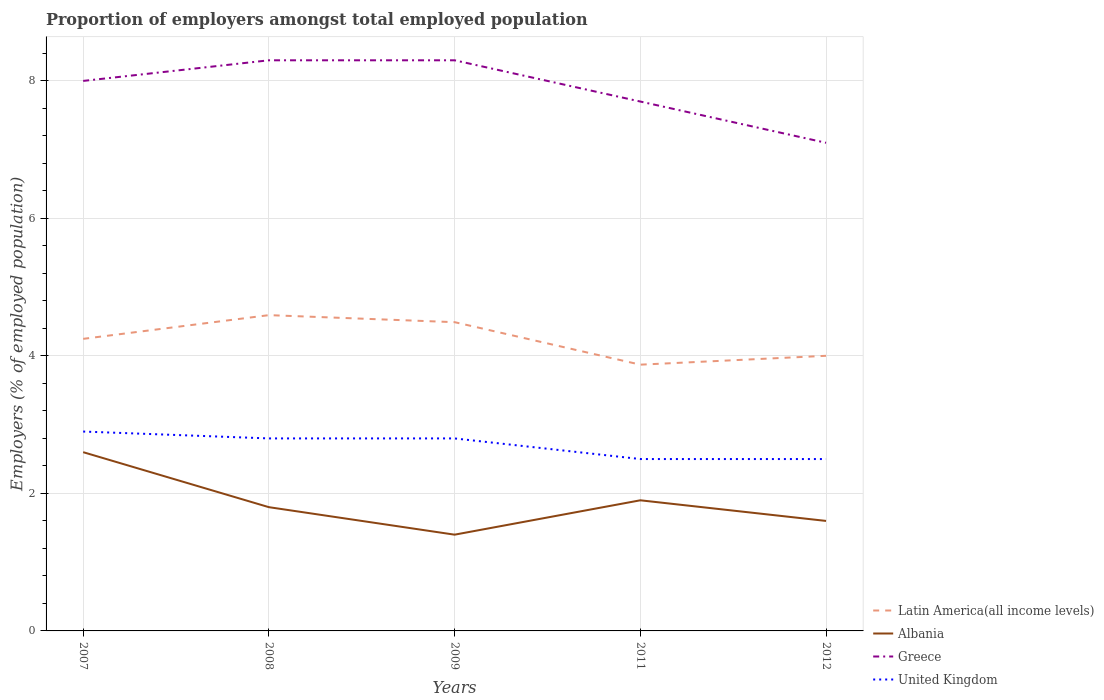How many different coloured lines are there?
Offer a very short reply. 4. Does the line corresponding to Latin America(all income levels) intersect with the line corresponding to United Kingdom?
Your response must be concise. No. What is the total proportion of employers in United Kingdom in the graph?
Ensure brevity in your answer.  0.4. What is the difference between the highest and the second highest proportion of employers in Greece?
Your answer should be very brief. 1.2. What is the difference between the highest and the lowest proportion of employers in Greece?
Ensure brevity in your answer.  3. Is the proportion of employers in Greece strictly greater than the proportion of employers in United Kingdom over the years?
Provide a short and direct response. No. What is the difference between two consecutive major ticks on the Y-axis?
Your response must be concise. 2. Does the graph contain grids?
Provide a short and direct response. Yes. Where does the legend appear in the graph?
Keep it short and to the point. Bottom right. What is the title of the graph?
Make the answer very short. Proportion of employers amongst total employed population. What is the label or title of the Y-axis?
Keep it short and to the point. Employers (% of employed population). What is the Employers (% of employed population) of Latin America(all income levels) in 2007?
Make the answer very short. 4.25. What is the Employers (% of employed population) in Albania in 2007?
Offer a terse response. 2.6. What is the Employers (% of employed population) of Greece in 2007?
Offer a terse response. 8. What is the Employers (% of employed population) in United Kingdom in 2007?
Offer a terse response. 2.9. What is the Employers (% of employed population) of Latin America(all income levels) in 2008?
Your answer should be very brief. 4.59. What is the Employers (% of employed population) in Albania in 2008?
Provide a succinct answer. 1.8. What is the Employers (% of employed population) of Greece in 2008?
Keep it short and to the point. 8.3. What is the Employers (% of employed population) in United Kingdom in 2008?
Your answer should be very brief. 2.8. What is the Employers (% of employed population) of Latin America(all income levels) in 2009?
Your response must be concise. 4.49. What is the Employers (% of employed population) of Albania in 2009?
Provide a succinct answer. 1.4. What is the Employers (% of employed population) in Greece in 2009?
Provide a succinct answer. 8.3. What is the Employers (% of employed population) in United Kingdom in 2009?
Ensure brevity in your answer.  2.8. What is the Employers (% of employed population) in Latin America(all income levels) in 2011?
Your answer should be compact. 3.87. What is the Employers (% of employed population) in Albania in 2011?
Offer a terse response. 1.9. What is the Employers (% of employed population) in Greece in 2011?
Offer a very short reply. 7.7. What is the Employers (% of employed population) in Latin America(all income levels) in 2012?
Give a very brief answer. 4. What is the Employers (% of employed population) in Albania in 2012?
Give a very brief answer. 1.6. What is the Employers (% of employed population) of Greece in 2012?
Offer a terse response. 7.1. Across all years, what is the maximum Employers (% of employed population) in Latin America(all income levels)?
Keep it short and to the point. 4.59. Across all years, what is the maximum Employers (% of employed population) of Albania?
Your answer should be compact. 2.6. Across all years, what is the maximum Employers (% of employed population) in Greece?
Provide a succinct answer. 8.3. Across all years, what is the maximum Employers (% of employed population) in United Kingdom?
Ensure brevity in your answer.  2.9. Across all years, what is the minimum Employers (% of employed population) of Latin America(all income levels)?
Offer a terse response. 3.87. Across all years, what is the minimum Employers (% of employed population) in Albania?
Provide a succinct answer. 1.4. Across all years, what is the minimum Employers (% of employed population) in Greece?
Offer a terse response. 7.1. Across all years, what is the minimum Employers (% of employed population) of United Kingdom?
Your answer should be very brief. 2.5. What is the total Employers (% of employed population) in Latin America(all income levels) in the graph?
Your response must be concise. 21.21. What is the total Employers (% of employed population) of Albania in the graph?
Keep it short and to the point. 9.3. What is the total Employers (% of employed population) in Greece in the graph?
Keep it short and to the point. 39.4. What is the difference between the Employers (% of employed population) in Latin America(all income levels) in 2007 and that in 2008?
Offer a very short reply. -0.34. What is the difference between the Employers (% of employed population) of Albania in 2007 and that in 2008?
Keep it short and to the point. 0.8. What is the difference between the Employers (% of employed population) in Greece in 2007 and that in 2008?
Offer a very short reply. -0.3. What is the difference between the Employers (% of employed population) of United Kingdom in 2007 and that in 2008?
Ensure brevity in your answer.  0.1. What is the difference between the Employers (% of employed population) in Latin America(all income levels) in 2007 and that in 2009?
Your response must be concise. -0.24. What is the difference between the Employers (% of employed population) of Albania in 2007 and that in 2009?
Provide a short and direct response. 1.2. What is the difference between the Employers (% of employed population) of Greece in 2007 and that in 2009?
Provide a succinct answer. -0.3. What is the difference between the Employers (% of employed population) in Latin America(all income levels) in 2007 and that in 2011?
Keep it short and to the point. 0.38. What is the difference between the Employers (% of employed population) in Albania in 2007 and that in 2011?
Your answer should be compact. 0.7. What is the difference between the Employers (% of employed population) in Greece in 2007 and that in 2011?
Provide a succinct answer. 0.3. What is the difference between the Employers (% of employed population) in United Kingdom in 2007 and that in 2011?
Keep it short and to the point. 0.4. What is the difference between the Employers (% of employed population) in Latin America(all income levels) in 2007 and that in 2012?
Make the answer very short. 0.25. What is the difference between the Employers (% of employed population) of Greece in 2007 and that in 2012?
Keep it short and to the point. 0.9. What is the difference between the Employers (% of employed population) of United Kingdom in 2007 and that in 2012?
Offer a very short reply. 0.4. What is the difference between the Employers (% of employed population) in Latin America(all income levels) in 2008 and that in 2009?
Ensure brevity in your answer.  0.1. What is the difference between the Employers (% of employed population) in Albania in 2008 and that in 2009?
Your answer should be compact. 0.4. What is the difference between the Employers (% of employed population) in United Kingdom in 2008 and that in 2009?
Your answer should be very brief. 0. What is the difference between the Employers (% of employed population) of Latin America(all income levels) in 2008 and that in 2011?
Make the answer very short. 0.72. What is the difference between the Employers (% of employed population) in Latin America(all income levels) in 2008 and that in 2012?
Your response must be concise. 0.59. What is the difference between the Employers (% of employed population) of Greece in 2008 and that in 2012?
Offer a terse response. 1.2. What is the difference between the Employers (% of employed population) of United Kingdom in 2008 and that in 2012?
Keep it short and to the point. 0.3. What is the difference between the Employers (% of employed population) of Latin America(all income levels) in 2009 and that in 2011?
Provide a short and direct response. 0.62. What is the difference between the Employers (% of employed population) of Albania in 2009 and that in 2011?
Your answer should be very brief. -0.5. What is the difference between the Employers (% of employed population) of Greece in 2009 and that in 2011?
Provide a short and direct response. 0.6. What is the difference between the Employers (% of employed population) in Latin America(all income levels) in 2009 and that in 2012?
Your answer should be compact. 0.49. What is the difference between the Employers (% of employed population) in Albania in 2009 and that in 2012?
Your answer should be compact. -0.2. What is the difference between the Employers (% of employed population) in United Kingdom in 2009 and that in 2012?
Your answer should be compact. 0.3. What is the difference between the Employers (% of employed population) of Latin America(all income levels) in 2011 and that in 2012?
Your answer should be compact. -0.13. What is the difference between the Employers (% of employed population) in Greece in 2011 and that in 2012?
Provide a succinct answer. 0.6. What is the difference between the Employers (% of employed population) of Latin America(all income levels) in 2007 and the Employers (% of employed population) of Albania in 2008?
Ensure brevity in your answer.  2.45. What is the difference between the Employers (% of employed population) in Latin America(all income levels) in 2007 and the Employers (% of employed population) in Greece in 2008?
Your answer should be compact. -4.05. What is the difference between the Employers (% of employed population) in Latin America(all income levels) in 2007 and the Employers (% of employed population) in United Kingdom in 2008?
Ensure brevity in your answer.  1.45. What is the difference between the Employers (% of employed population) of Albania in 2007 and the Employers (% of employed population) of Greece in 2008?
Give a very brief answer. -5.7. What is the difference between the Employers (% of employed population) of Latin America(all income levels) in 2007 and the Employers (% of employed population) of Albania in 2009?
Offer a very short reply. 2.85. What is the difference between the Employers (% of employed population) in Latin America(all income levels) in 2007 and the Employers (% of employed population) in Greece in 2009?
Your response must be concise. -4.05. What is the difference between the Employers (% of employed population) of Latin America(all income levels) in 2007 and the Employers (% of employed population) of United Kingdom in 2009?
Your answer should be very brief. 1.45. What is the difference between the Employers (% of employed population) in Latin America(all income levels) in 2007 and the Employers (% of employed population) in Albania in 2011?
Provide a succinct answer. 2.35. What is the difference between the Employers (% of employed population) in Latin America(all income levels) in 2007 and the Employers (% of employed population) in Greece in 2011?
Ensure brevity in your answer.  -3.45. What is the difference between the Employers (% of employed population) in Latin America(all income levels) in 2007 and the Employers (% of employed population) in United Kingdom in 2011?
Offer a terse response. 1.75. What is the difference between the Employers (% of employed population) of Albania in 2007 and the Employers (% of employed population) of United Kingdom in 2011?
Make the answer very short. 0.1. What is the difference between the Employers (% of employed population) of Greece in 2007 and the Employers (% of employed population) of United Kingdom in 2011?
Your answer should be very brief. 5.5. What is the difference between the Employers (% of employed population) of Latin America(all income levels) in 2007 and the Employers (% of employed population) of Albania in 2012?
Keep it short and to the point. 2.65. What is the difference between the Employers (% of employed population) of Latin America(all income levels) in 2007 and the Employers (% of employed population) of Greece in 2012?
Provide a succinct answer. -2.85. What is the difference between the Employers (% of employed population) in Latin America(all income levels) in 2007 and the Employers (% of employed population) in United Kingdom in 2012?
Provide a succinct answer. 1.75. What is the difference between the Employers (% of employed population) in Latin America(all income levels) in 2008 and the Employers (% of employed population) in Albania in 2009?
Your answer should be compact. 3.19. What is the difference between the Employers (% of employed population) of Latin America(all income levels) in 2008 and the Employers (% of employed population) of Greece in 2009?
Give a very brief answer. -3.71. What is the difference between the Employers (% of employed population) in Latin America(all income levels) in 2008 and the Employers (% of employed population) in United Kingdom in 2009?
Offer a very short reply. 1.79. What is the difference between the Employers (% of employed population) of Albania in 2008 and the Employers (% of employed population) of United Kingdom in 2009?
Your response must be concise. -1. What is the difference between the Employers (% of employed population) in Greece in 2008 and the Employers (% of employed population) in United Kingdom in 2009?
Offer a very short reply. 5.5. What is the difference between the Employers (% of employed population) in Latin America(all income levels) in 2008 and the Employers (% of employed population) in Albania in 2011?
Ensure brevity in your answer.  2.69. What is the difference between the Employers (% of employed population) of Latin America(all income levels) in 2008 and the Employers (% of employed population) of Greece in 2011?
Your answer should be compact. -3.11. What is the difference between the Employers (% of employed population) in Latin America(all income levels) in 2008 and the Employers (% of employed population) in United Kingdom in 2011?
Your answer should be compact. 2.09. What is the difference between the Employers (% of employed population) in Albania in 2008 and the Employers (% of employed population) in Greece in 2011?
Offer a terse response. -5.9. What is the difference between the Employers (% of employed population) in Latin America(all income levels) in 2008 and the Employers (% of employed population) in Albania in 2012?
Offer a very short reply. 2.99. What is the difference between the Employers (% of employed population) of Latin America(all income levels) in 2008 and the Employers (% of employed population) of Greece in 2012?
Ensure brevity in your answer.  -2.51. What is the difference between the Employers (% of employed population) in Latin America(all income levels) in 2008 and the Employers (% of employed population) in United Kingdom in 2012?
Provide a succinct answer. 2.09. What is the difference between the Employers (% of employed population) of Albania in 2008 and the Employers (% of employed population) of Greece in 2012?
Offer a very short reply. -5.3. What is the difference between the Employers (% of employed population) of Albania in 2008 and the Employers (% of employed population) of United Kingdom in 2012?
Your answer should be very brief. -0.7. What is the difference between the Employers (% of employed population) in Latin America(all income levels) in 2009 and the Employers (% of employed population) in Albania in 2011?
Make the answer very short. 2.59. What is the difference between the Employers (% of employed population) in Latin America(all income levels) in 2009 and the Employers (% of employed population) in Greece in 2011?
Offer a very short reply. -3.21. What is the difference between the Employers (% of employed population) of Latin America(all income levels) in 2009 and the Employers (% of employed population) of United Kingdom in 2011?
Provide a succinct answer. 1.99. What is the difference between the Employers (% of employed population) in Albania in 2009 and the Employers (% of employed population) in Greece in 2011?
Ensure brevity in your answer.  -6.3. What is the difference between the Employers (% of employed population) of Albania in 2009 and the Employers (% of employed population) of United Kingdom in 2011?
Provide a short and direct response. -1.1. What is the difference between the Employers (% of employed population) of Latin America(all income levels) in 2009 and the Employers (% of employed population) of Albania in 2012?
Offer a very short reply. 2.89. What is the difference between the Employers (% of employed population) in Latin America(all income levels) in 2009 and the Employers (% of employed population) in Greece in 2012?
Offer a terse response. -2.61. What is the difference between the Employers (% of employed population) in Latin America(all income levels) in 2009 and the Employers (% of employed population) in United Kingdom in 2012?
Your answer should be compact. 1.99. What is the difference between the Employers (% of employed population) of Albania in 2009 and the Employers (% of employed population) of Greece in 2012?
Your response must be concise. -5.7. What is the difference between the Employers (% of employed population) of Albania in 2009 and the Employers (% of employed population) of United Kingdom in 2012?
Offer a very short reply. -1.1. What is the difference between the Employers (% of employed population) in Latin America(all income levels) in 2011 and the Employers (% of employed population) in Albania in 2012?
Provide a succinct answer. 2.27. What is the difference between the Employers (% of employed population) in Latin America(all income levels) in 2011 and the Employers (% of employed population) in Greece in 2012?
Offer a terse response. -3.23. What is the difference between the Employers (% of employed population) in Latin America(all income levels) in 2011 and the Employers (% of employed population) in United Kingdom in 2012?
Your answer should be very brief. 1.37. What is the difference between the Employers (% of employed population) in Albania in 2011 and the Employers (% of employed population) in Greece in 2012?
Offer a very short reply. -5.2. What is the difference between the Employers (% of employed population) in Albania in 2011 and the Employers (% of employed population) in United Kingdom in 2012?
Offer a very short reply. -0.6. What is the average Employers (% of employed population) in Latin America(all income levels) per year?
Give a very brief answer. 4.24. What is the average Employers (% of employed population) of Albania per year?
Keep it short and to the point. 1.86. What is the average Employers (% of employed population) in Greece per year?
Give a very brief answer. 7.88. In the year 2007, what is the difference between the Employers (% of employed population) of Latin America(all income levels) and Employers (% of employed population) of Albania?
Ensure brevity in your answer.  1.65. In the year 2007, what is the difference between the Employers (% of employed population) in Latin America(all income levels) and Employers (% of employed population) in Greece?
Ensure brevity in your answer.  -3.75. In the year 2007, what is the difference between the Employers (% of employed population) in Latin America(all income levels) and Employers (% of employed population) in United Kingdom?
Give a very brief answer. 1.35. In the year 2007, what is the difference between the Employers (% of employed population) in Albania and Employers (% of employed population) in United Kingdom?
Your answer should be compact. -0.3. In the year 2007, what is the difference between the Employers (% of employed population) of Greece and Employers (% of employed population) of United Kingdom?
Keep it short and to the point. 5.1. In the year 2008, what is the difference between the Employers (% of employed population) of Latin America(all income levels) and Employers (% of employed population) of Albania?
Offer a very short reply. 2.79. In the year 2008, what is the difference between the Employers (% of employed population) in Latin America(all income levels) and Employers (% of employed population) in Greece?
Your response must be concise. -3.71. In the year 2008, what is the difference between the Employers (% of employed population) of Latin America(all income levels) and Employers (% of employed population) of United Kingdom?
Keep it short and to the point. 1.79. In the year 2009, what is the difference between the Employers (% of employed population) of Latin America(all income levels) and Employers (% of employed population) of Albania?
Your answer should be very brief. 3.09. In the year 2009, what is the difference between the Employers (% of employed population) of Latin America(all income levels) and Employers (% of employed population) of Greece?
Your response must be concise. -3.81. In the year 2009, what is the difference between the Employers (% of employed population) of Latin America(all income levels) and Employers (% of employed population) of United Kingdom?
Ensure brevity in your answer.  1.69. In the year 2009, what is the difference between the Employers (% of employed population) of Albania and Employers (% of employed population) of Greece?
Offer a very short reply. -6.9. In the year 2009, what is the difference between the Employers (% of employed population) in Greece and Employers (% of employed population) in United Kingdom?
Make the answer very short. 5.5. In the year 2011, what is the difference between the Employers (% of employed population) of Latin America(all income levels) and Employers (% of employed population) of Albania?
Your response must be concise. 1.97. In the year 2011, what is the difference between the Employers (% of employed population) of Latin America(all income levels) and Employers (% of employed population) of Greece?
Offer a very short reply. -3.83. In the year 2011, what is the difference between the Employers (% of employed population) of Latin America(all income levels) and Employers (% of employed population) of United Kingdom?
Provide a succinct answer. 1.37. In the year 2012, what is the difference between the Employers (% of employed population) of Latin America(all income levels) and Employers (% of employed population) of Albania?
Your answer should be compact. 2.4. In the year 2012, what is the difference between the Employers (% of employed population) in Latin America(all income levels) and Employers (% of employed population) in Greece?
Your answer should be very brief. -3.1. In the year 2012, what is the difference between the Employers (% of employed population) of Latin America(all income levels) and Employers (% of employed population) of United Kingdom?
Your answer should be very brief. 1.5. In the year 2012, what is the difference between the Employers (% of employed population) in Albania and Employers (% of employed population) in Greece?
Provide a short and direct response. -5.5. What is the ratio of the Employers (% of employed population) in Latin America(all income levels) in 2007 to that in 2008?
Ensure brevity in your answer.  0.92. What is the ratio of the Employers (% of employed population) in Albania in 2007 to that in 2008?
Your answer should be compact. 1.44. What is the ratio of the Employers (% of employed population) in Greece in 2007 to that in 2008?
Your answer should be very brief. 0.96. What is the ratio of the Employers (% of employed population) of United Kingdom in 2007 to that in 2008?
Offer a terse response. 1.04. What is the ratio of the Employers (% of employed population) of Latin America(all income levels) in 2007 to that in 2009?
Provide a succinct answer. 0.95. What is the ratio of the Employers (% of employed population) in Albania in 2007 to that in 2009?
Make the answer very short. 1.86. What is the ratio of the Employers (% of employed population) of Greece in 2007 to that in 2009?
Provide a short and direct response. 0.96. What is the ratio of the Employers (% of employed population) in United Kingdom in 2007 to that in 2009?
Keep it short and to the point. 1.04. What is the ratio of the Employers (% of employed population) in Latin America(all income levels) in 2007 to that in 2011?
Provide a short and direct response. 1.1. What is the ratio of the Employers (% of employed population) of Albania in 2007 to that in 2011?
Offer a terse response. 1.37. What is the ratio of the Employers (% of employed population) of Greece in 2007 to that in 2011?
Your response must be concise. 1.04. What is the ratio of the Employers (% of employed population) in United Kingdom in 2007 to that in 2011?
Keep it short and to the point. 1.16. What is the ratio of the Employers (% of employed population) of Latin America(all income levels) in 2007 to that in 2012?
Give a very brief answer. 1.06. What is the ratio of the Employers (% of employed population) of Albania in 2007 to that in 2012?
Give a very brief answer. 1.62. What is the ratio of the Employers (% of employed population) in Greece in 2007 to that in 2012?
Ensure brevity in your answer.  1.13. What is the ratio of the Employers (% of employed population) of United Kingdom in 2007 to that in 2012?
Your answer should be very brief. 1.16. What is the ratio of the Employers (% of employed population) of Latin America(all income levels) in 2008 to that in 2009?
Your answer should be very brief. 1.02. What is the ratio of the Employers (% of employed population) of Latin America(all income levels) in 2008 to that in 2011?
Offer a very short reply. 1.19. What is the ratio of the Employers (% of employed population) of Greece in 2008 to that in 2011?
Your answer should be very brief. 1.08. What is the ratio of the Employers (% of employed population) in United Kingdom in 2008 to that in 2011?
Offer a very short reply. 1.12. What is the ratio of the Employers (% of employed population) in Latin America(all income levels) in 2008 to that in 2012?
Your response must be concise. 1.15. What is the ratio of the Employers (% of employed population) in Greece in 2008 to that in 2012?
Make the answer very short. 1.17. What is the ratio of the Employers (% of employed population) of United Kingdom in 2008 to that in 2012?
Offer a terse response. 1.12. What is the ratio of the Employers (% of employed population) in Latin America(all income levels) in 2009 to that in 2011?
Your response must be concise. 1.16. What is the ratio of the Employers (% of employed population) of Albania in 2009 to that in 2011?
Ensure brevity in your answer.  0.74. What is the ratio of the Employers (% of employed population) of Greece in 2009 to that in 2011?
Give a very brief answer. 1.08. What is the ratio of the Employers (% of employed population) in United Kingdom in 2009 to that in 2011?
Your answer should be very brief. 1.12. What is the ratio of the Employers (% of employed population) in Latin America(all income levels) in 2009 to that in 2012?
Provide a succinct answer. 1.12. What is the ratio of the Employers (% of employed population) in Greece in 2009 to that in 2012?
Your response must be concise. 1.17. What is the ratio of the Employers (% of employed population) in United Kingdom in 2009 to that in 2012?
Your response must be concise. 1.12. What is the ratio of the Employers (% of employed population) of Latin America(all income levels) in 2011 to that in 2012?
Your response must be concise. 0.97. What is the ratio of the Employers (% of employed population) of Albania in 2011 to that in 2012?
Give a very brief answer. 1.19. What is the ratio of the Employers (% of employed population) of Greece in 2011 to that in 2012?
Give a very brief answer. 1.08. What is the difference between the highest and the second highest Employers (% of employed population) of Latin America(all income levels)?
Provide a succinct answer. 0.1. What is the difference between the highest and the lowest Employers (% of employed population) of Latin America(all income levels)?
Your answer should be very brief. 0.72. What is the difference between the highest and the lowest Employers (% of employed population) in Greece?
Keep it short and to the point. 1.2. 